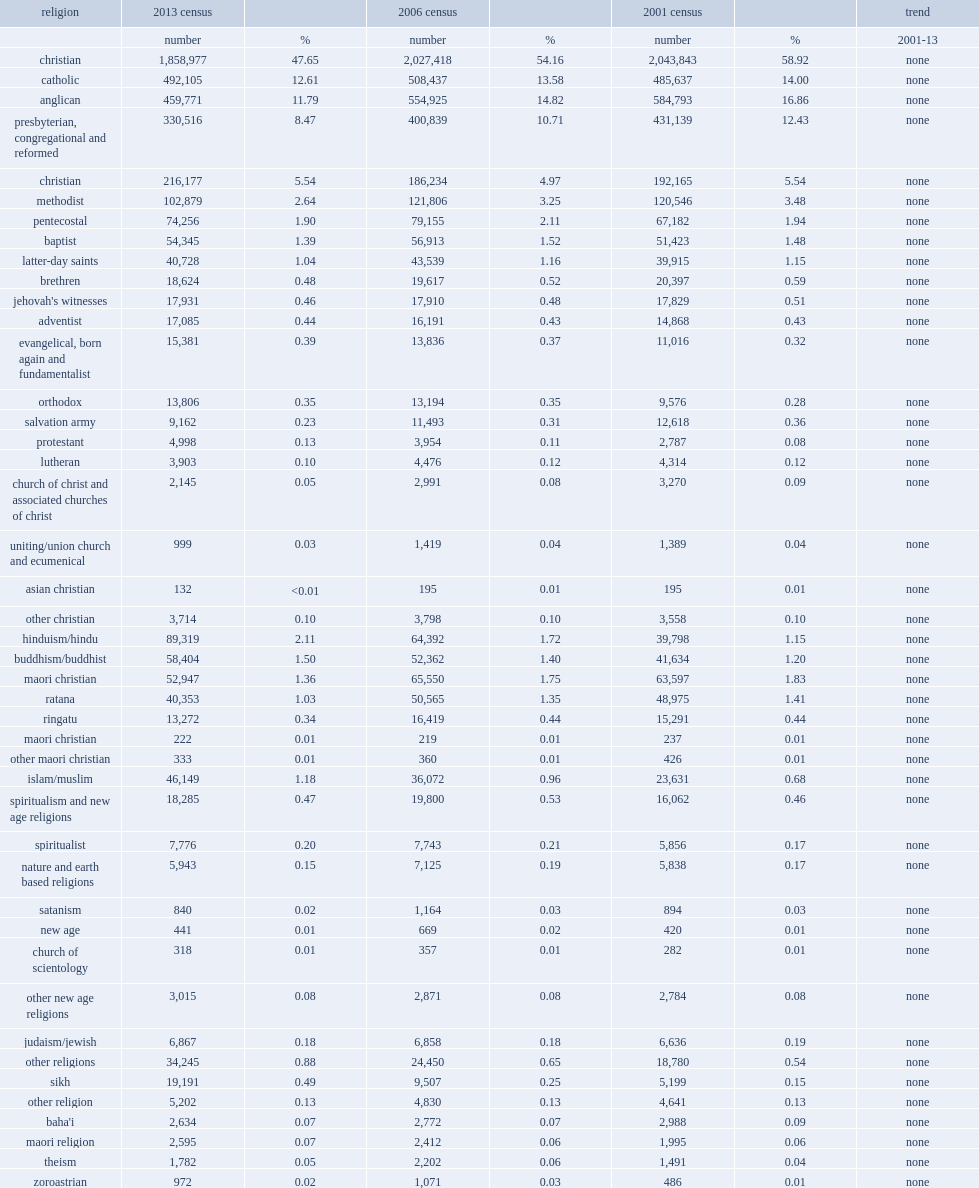What was the number of anglican numbers in 2013? 459771.0. 